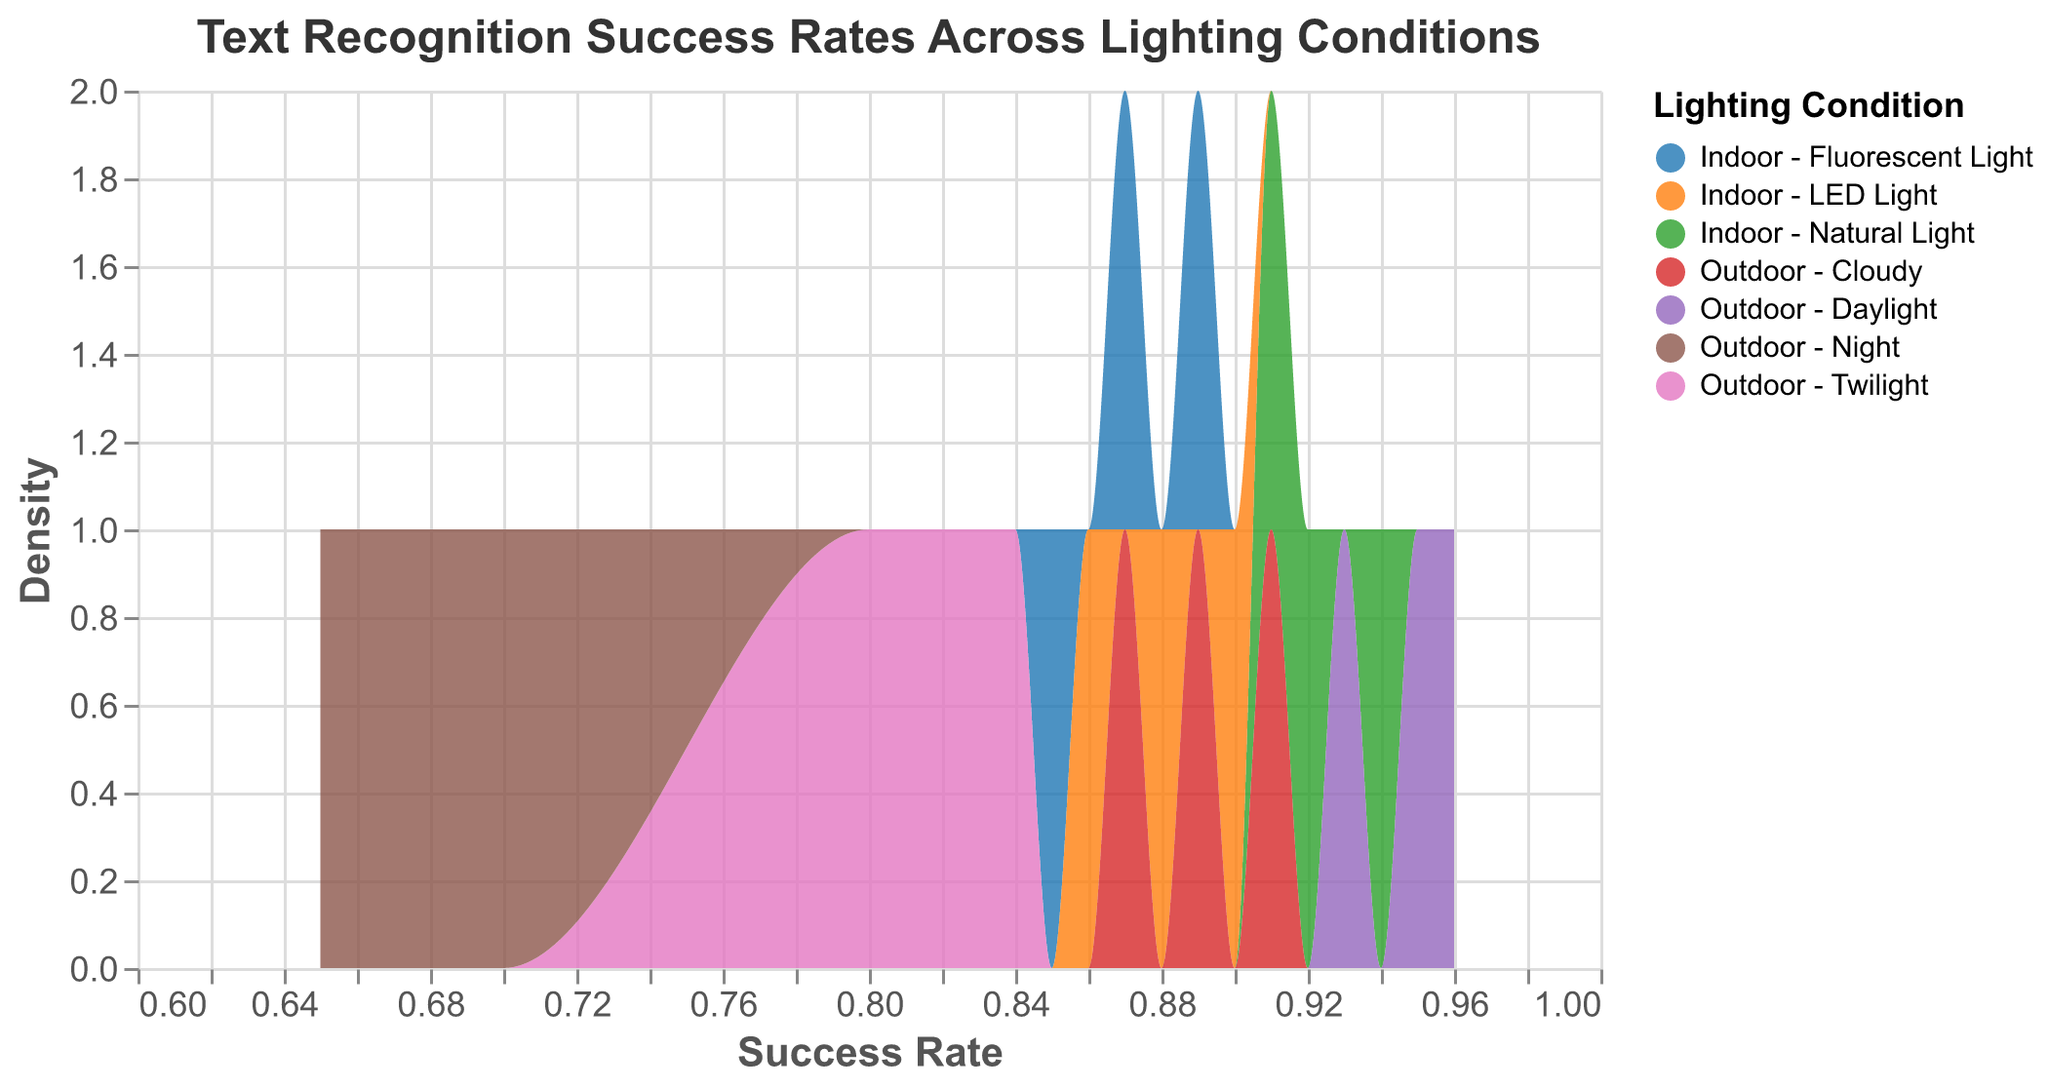What is the title of the figure? The title is usually at the top of the figure. In this case, the title is clearly specified in the "title" dictionary of the code provided.
Answer: Text Recognition Success Rates Across Lighting Conditions What are the axes labels of the plot? The axes labels can be found in the "x" and "y" encoding sections. The x-axis is labeled "Success Rate", and the y-axis is labeled "Density".
Answer: Success Rate (x-axis), Density (y-axis) How many different lighting conditions are represented in the figure? By looking at the distinct categories under the "Lighting Condition" field in the data and the corresponding color legend, we can count the number of lighting conditions. There are six lighting conditions.
Answer: 6 Which lighting condition has the highest overall text recognition success rate? We need to scan the density plots for the lighting condition whose peak distribution is at the highest success rate. From the data, "Outdoor - Daylight" has the highest success rates ranging from 0.93 to 0.96.
Answer: Outdoor - Daylight Which lighting condition shows the lowest recognition success rate? We look for the lighting condition with peaks or high density at the lower end of the success rate axis. From the data, "Outdoor - Night" shows the lowest success rate, ranging from 0.65 to 0.70.
Answer: Outdoor - Night Are indoor lighting conditions generally better for text recognition success than outdoor lighting conditions? Compare the range and distribution of success rates between indoor lighting conditions (Fluorescent, Natural, LED) and outdoor lighting conditions (Daylight, Twilight, Night, Cloudy). Generally, indoor lighting conditions like Fluorescent, Natural, and LED show higher and more consistent success rates compared to outdoor twilight and night but not more than daylight.
Answer: Yes for twilight and night, no for daylight What is the most consistent lighting condition in terms of text recognition success rate? Consistency can be inferred from the density plot width and uniformity. The narrower and taller the plot, the more consistent the success rate. "Indoor - Natural Light" appears to be very consistent with success rates closely around 0.92 to 0.94.
Answer: Indoor - Natural Light What lighting condition(s) have overlapping regions in terms of their success rates? Identify regions on the x-axis (Success Rate) where density plots for different lighting conditions overlap. There is an overlap between "Indoor - LED Light" and "Indoor - Fluorescent Light" around success rates of 0.87 and 0.88. Also, "Outdoor - Cloudy" and "Indoor - Natural Light" overlap around 0.89 to 0.91.
Answer: Indoor - LED Light and Fluorescent Light, Outdoor - Cloudy and Indoor - Natural Light 